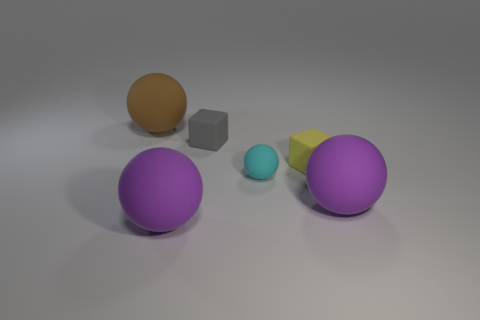How many large balls are both left of the tiny cyan object and in front of the big brown rubber thing?
Your response must be concise. 1. What is the tiny thing that is behind the cyan ball and in front of the gray matte object made of?
Keep it short and to the point. Rubber. Are there fewer brown rubber objects that are in front of the cyan matte ball than brown matte objects that are to the right of the gray matte thing?
Make the answer very short. No. What size is the brown thing that is made of the same material as the yellow object?
Make the answer very short. Large. There is another small thing that is the same shape as the brown rubber object; what is it made of?
Provide a succinct answer. Rubber. Is the large purple thing to the left of the tiny yellow matte cube made of the same material as the big sphere that is right of the cyan thing?
Offer a very short reply. Yes. The big matte thing behind the purple object right of the big purple object that is to the left of the tiny gray matte block is what color?
Provide a short and direct response. Brown. How many other things are the same shape as the tiny gray thing?
Your answer should be very brief. 1. How many objects are big rubber spheres or objects in front of the big brown matte object?
Your answer should be compact. 6. Are there any rubber cubes that have the same size as the yellow thing?
Your answer should be very brief. Yes. 